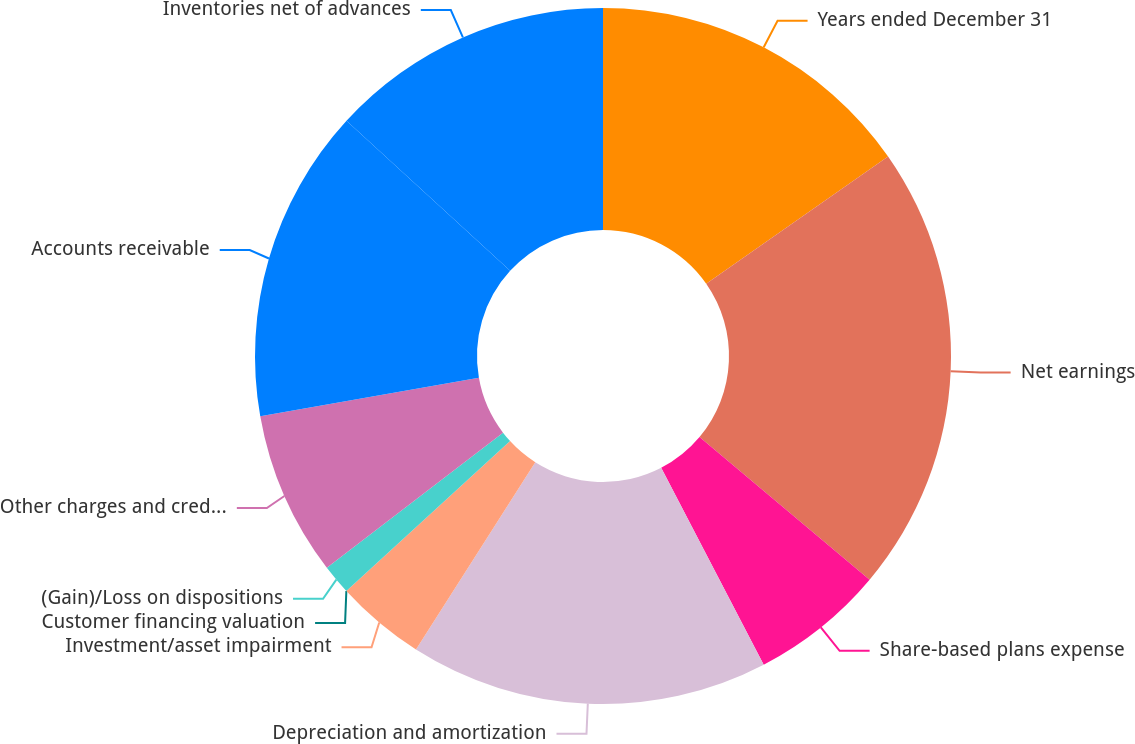Convert chart to OTSL. <chart><loc_0><loc_0><loc_500><loc_500><pie_chart><fcel>Years ended December 31<fcel>Net earnings<fcel>Share-based plans expense<fcel>Depreciation and amortization<fcel>Investment/asset impairment<fcel>Customer financing valuation<fcel>(Gain)/Loss on dispositions<fcel>Other charges and credits net<fcel>Accounts receivable<fcel>Inventories net of advances<nl><fcel>15.28%<fcel>20.83%<fcel>6.25%<fcel>16.67%<fcel>4.17%<fcel>0.0%<fcel>1.39%<fcel>7.64%<fcel>14.58%<fcel>13.19%<nl></chart> 